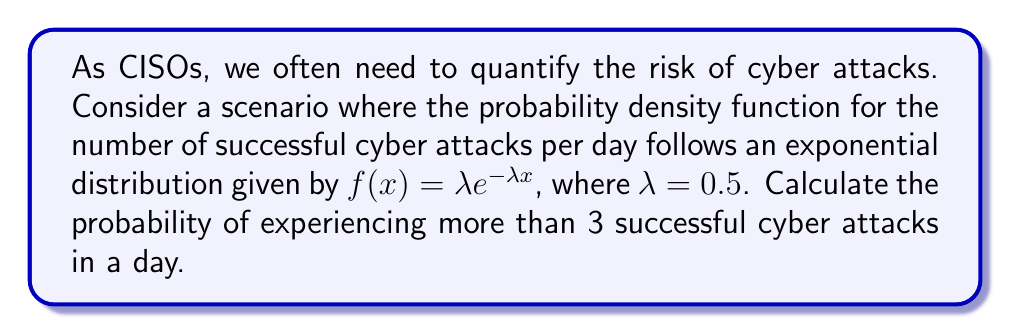Give your solution to this math problem. To solve this problem, we'll use integral calculus and the properties of the exponential distribution:

1) The probability of experiencing more than 3 attacks is equivalent to 1 minus the probability of experiencing 3 or fewer attacks:

   $P(X > 3) = 1 - P(X \leq 3)$

2) For a continuous distribution, we can calculate $P(X \leq 3)$ using the cumulative distribution function (CDF):

   $P(X \leq 3) = \int_0^3 f(x) dx$

3) Substituting our given probability density function:

   $P(X \leq 3) = \int_0^3 0.5e^{-0.5x} dx$

4) To solve this integral, we use the fundamental theorem of calculus:

   $P(X \leq 3) = [-e^{-0.5x}]_0^3$

5) Evaluating the integral:

   $P(X \leq 3) = -e^{-0.5(3)} - (-e^{-0.5(0)})$
   $= -e^{-1.5} + 1$
   $\approx 0.7769$

6) Therefore, the probability of experiencing more than 3 attacks is:

   $P(X > 3) = 1 - P(X \leq 3)$
   $= 1 - 0.7769$
   $\approx 0.2231$
Answer: $0.2231$ or $22.31\%$ 